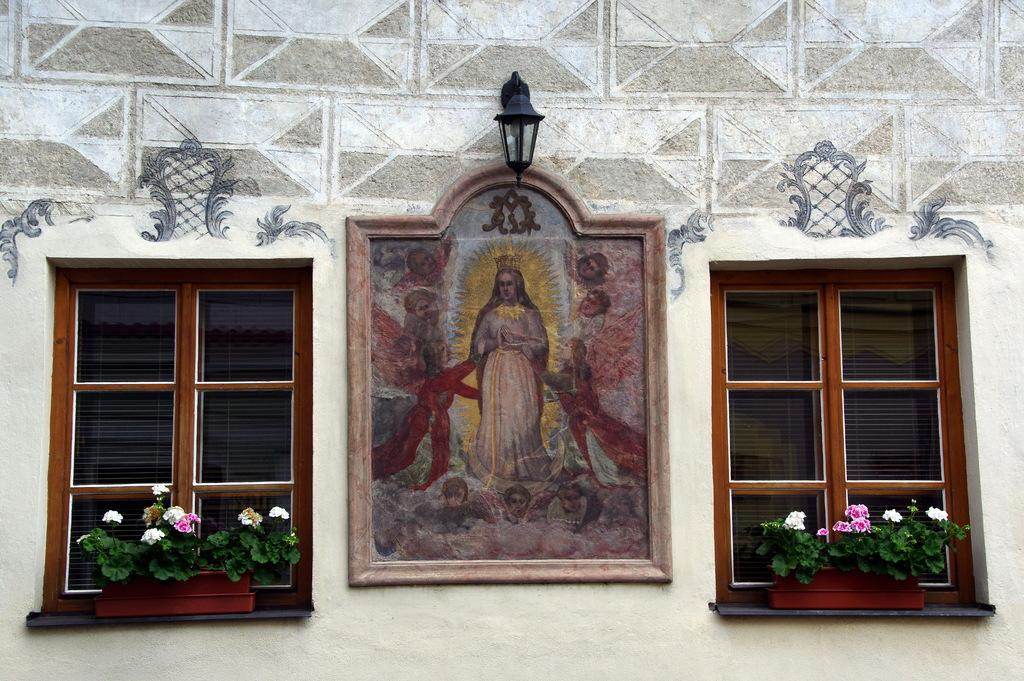What is hanging on the wall in the image? There is a frame on the wall in the image. What is also attached to the wall in the image? There is a light attached to the wall in the image. What can be seen in the background of the image? There are windows in the image. What type of vegetation is present in the image? There are plants with flowers in the image. Can you tell me how many birds are sitting on the frame in the image? There are no birds present in the image; it only features a frame, a light, windows, and plants with flowers. What type of respect is shown in the image? There is no indication of respect being shown in the image, as it only features a frame, a light, windows, and plants with flowers. 